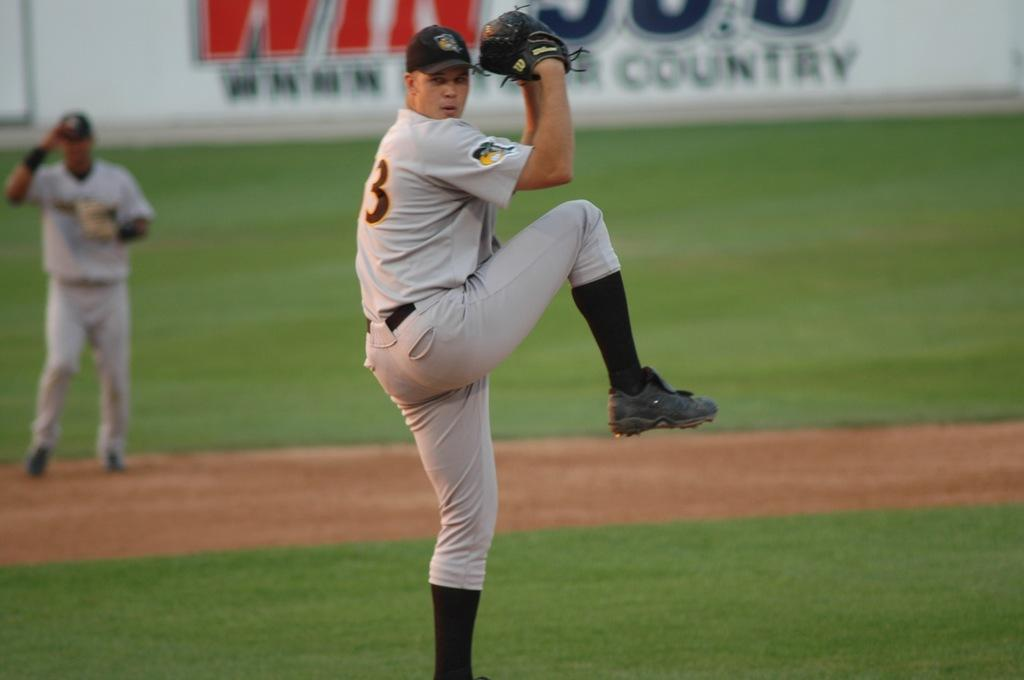Provide a one-sentence caption for the provided image. Baseball player wearing the numbe 3 about to pitch. 